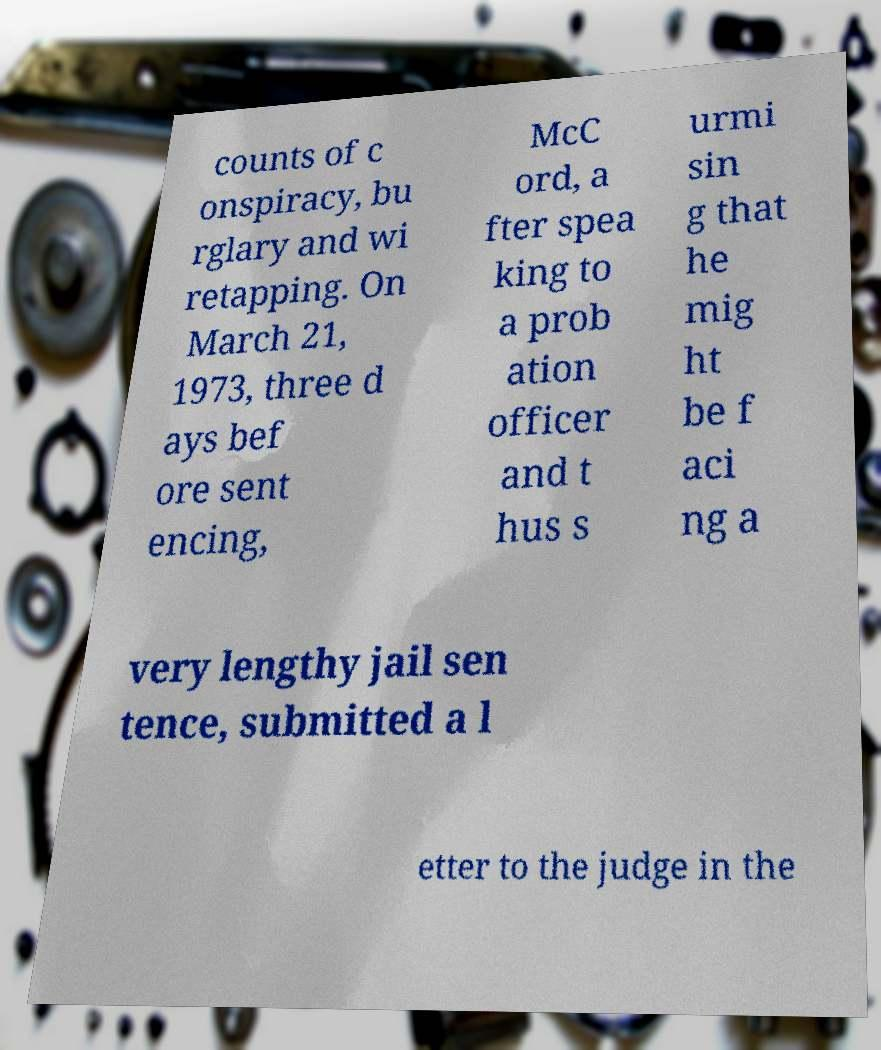Can you read and provide the text displayed in the image?This photo seems to have some interesting text. Can you extract and type it out for me? counts of c onspiracy, bu rglary and wi retapping. On March 21, 1973, three d ays bef ore sent encing, McC ord, a fter spea king to a prob ation officer and t hus s urmi sin g that he mig ht be f aci ng a very lengthy jail sen tence, submitted a l etter to the judge in the 